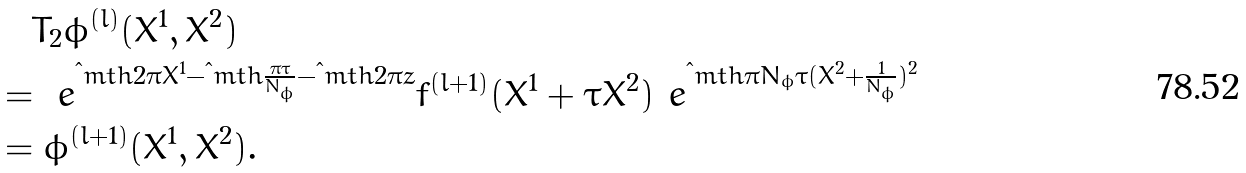Convert formula to latex. <formula><loc_0><loc_0><loc_500><loc_500>& \quad T _ { 2 } \phi ^ { ( l ) } ( X ^ { 1 } , X ^ { 2 } ) \\ & = \ e ^ { \i m t h 2 \pi X ^ { 1 } - \i m t h \frac { \pi \tau } { N _ { \phi } } - \i m t h 2 \pi z } f ^ { ( l + 1 ) } ( X ^ { 1 } + \tau X ^ { 2 } ) \ e ^ { \i m t h \pi N _ { \phi } \tau ( X ^ { 2 } + \frac { 1 } { N _ { \phi } } ) ^ { 2 } } \\ & = \phi ^ { ( l + 1 ) } ( X ^ { 1 } , X ^ { 2 } ) .</formula> 